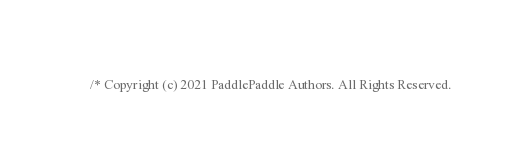Convert code to text. <code><loc_0><loc_0><loc_500><loc_500><_Cuda_>/* Copyright (c) 2021 PaddlePaddle Authors. All Rights Reserved.
</code> 